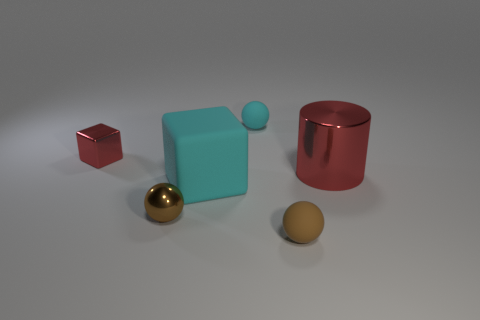Does the small red shiny thing have the same shape as the cyan rubber object that is in front of the small red metal object?
Provide a succinct answer. Yes. How many other objects are the same size as the red shiny cube?
Provide a short and direct response. 3. Is the number of blocks greater than the number of big shiny cylinders?
Ensure brevity in your answer.  Yes. What number of tiny matte things are behind the large metallic cylinder and in front of the big red cylinder?
Ensure brevity in your answer.  0. There is a small brown thing that is to the left of the rubber ball in front of the sphere that is behind the cylinder; what shape is it?
Your answer should be very brief. Sphere. Is there anything else that is the same shape as the big metallic object?
Offer a very short reply. No. How many cubes are cyan things or tiny cyan objects?
Give a very brief answer. 1. There is a matte ball in front of the big red metallic cylinder; does it have the same color as the big metal thing?
Offer a very short reply. No. What material is the red thing behind the red metallic object that is right of the cube that is in front of the small red cube made of?
Your response must be concise. Metal. Do the brown matte ball and the shiny cylinder have the same size?
Offer a terse response. No. 